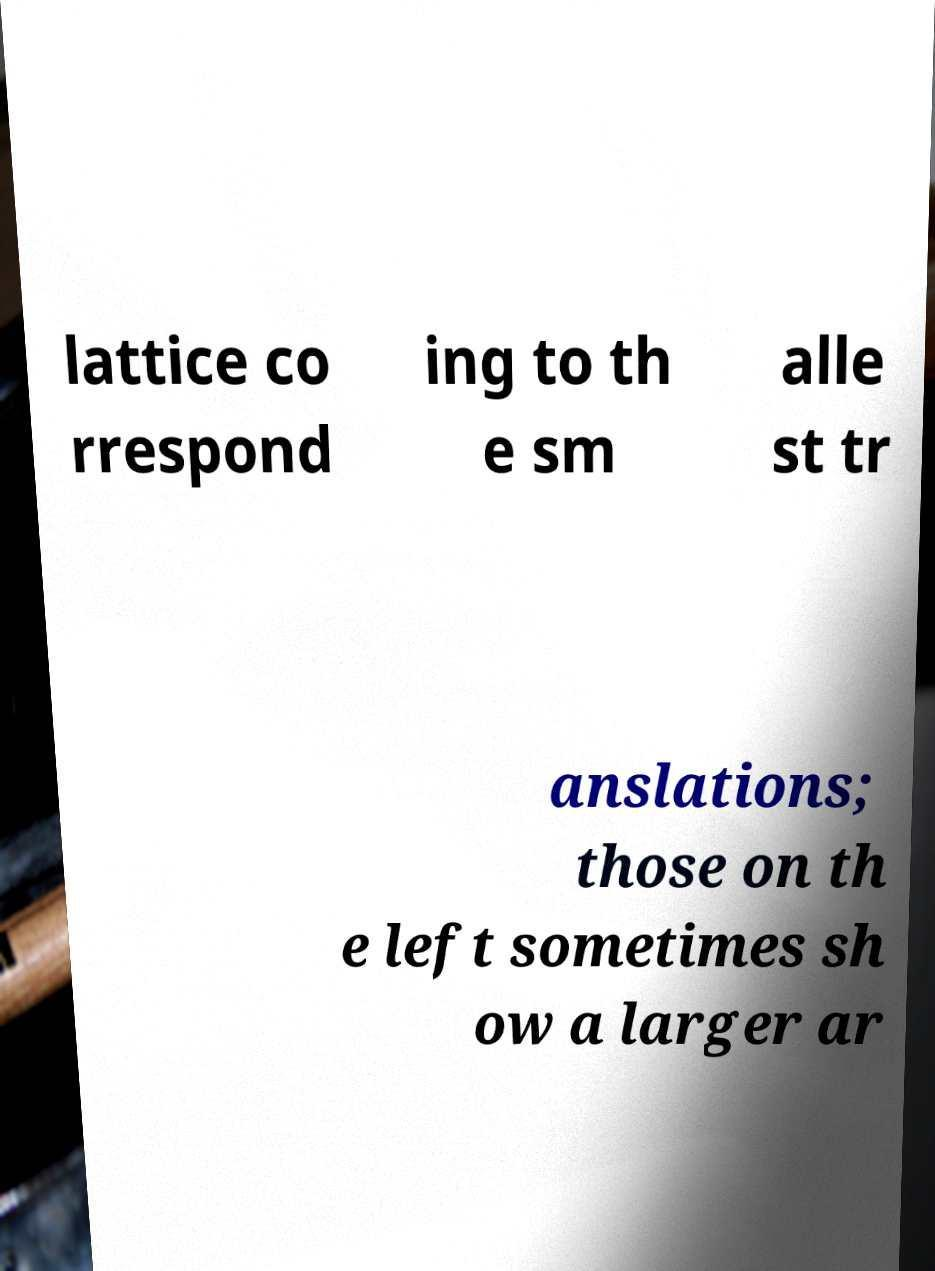Please identify and transcribe the text found in this image. lattice co rrespond ing to th e sm alle st tr anslations; those on th e left sometimes sh ow a larger ar 